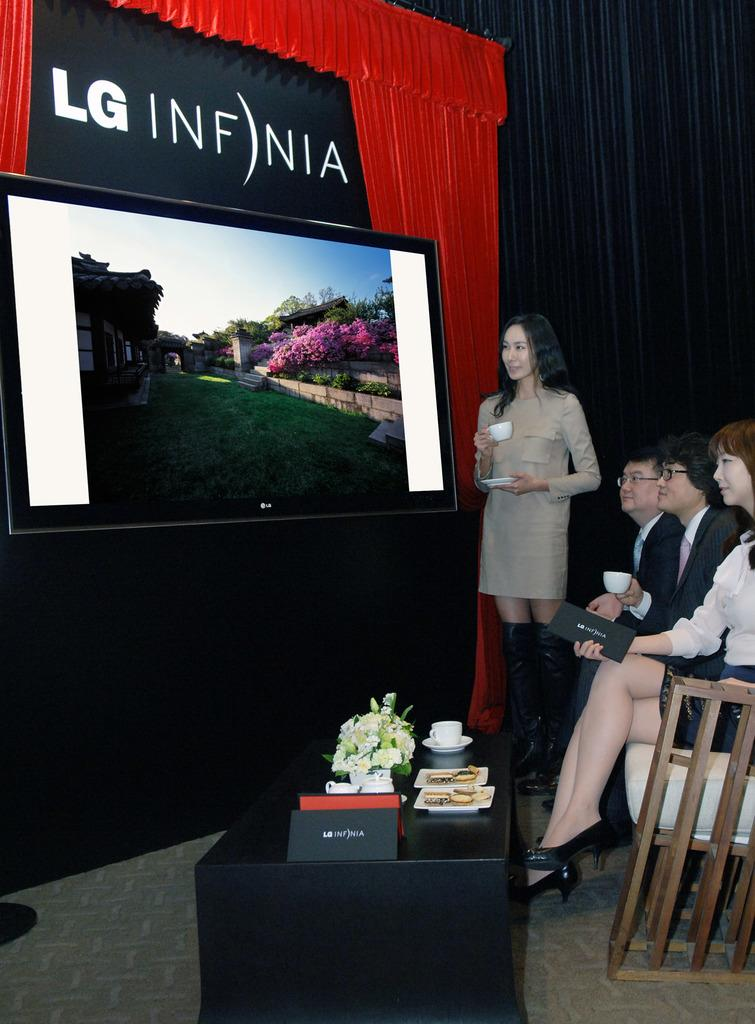Provide a one-sentence caption for the provided image. A television is on display showing the new LG Infnia. 